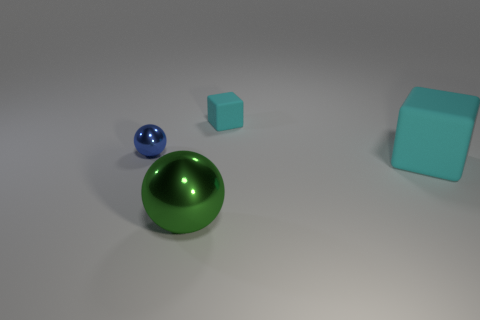There is a big thing behind the big green metal ball; is it the same color as the matte object that is behind the tiny blue sphere?
Keep it short and to the point. Yes. Is there any other thing that has the same color as the large metallic sphere?
Your answer should be compact. No. What color is the large shiny object in front of the metallic ball that is behind the large cyan matte cube?
Your answer should be very brief. Green. Are there any tiny purple shiny objects?
Provide a succinct answer. No. There is a thing that is to the left of the big cyan cube and in front of the small sphere; what color is it?
Offer a very short reply. Green. Does the cyan matte cube that is behind the blue object have the same size as the metallic ball behind the big cyan object?
Provide a short and direct response. Yes. What number of other objects are there of the same size as the blue metal thing?
Your response must be concise. 1. What number of objects are to the left of the ball in front of the large rubber block?
Make the answer very short. 1. Are there fewer small metal balls on the left side of the tiny metallic object than small brown metallic cylinders?
Offer a very short reply. No. There is a small object to the left of the large ball in front of the tiny blue shiny ball that is behind the large green ball; what is its shape?
Give a very brief answer. Sphere. 